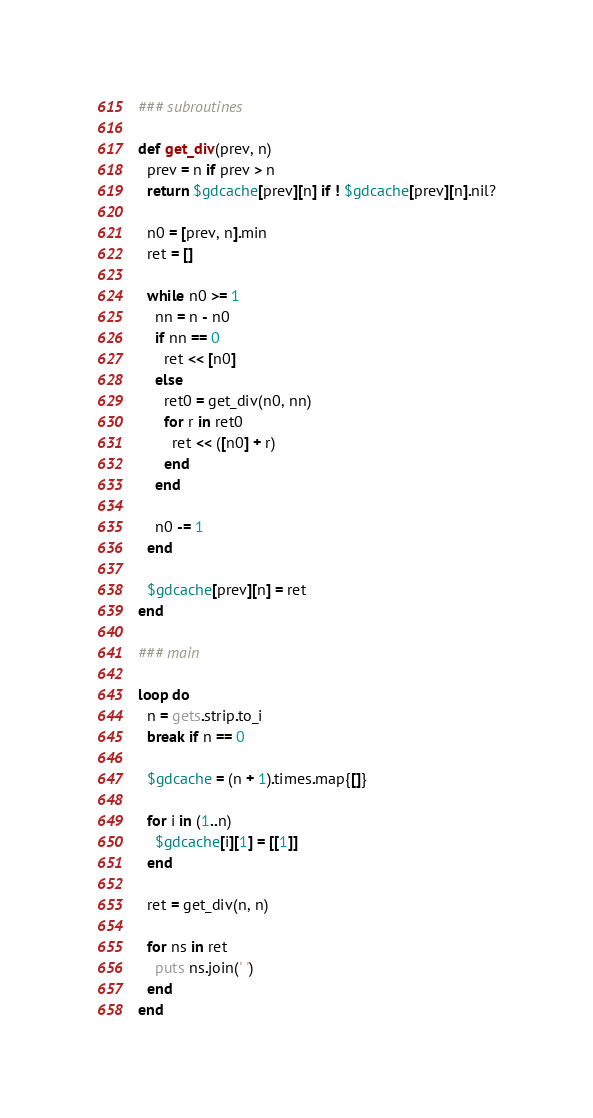<code> <loc_0><loc_0><loc_500><loc_500><_Ruby_>### subroutines

def get_div(prev, n)
  prev = n if prev > n
  return $gdcache[prev][n] if ! $gdcache[prev][n].nil?

  n0 = [prev, n].min
  ret = []

  while n0 >= 1
    nn = n - n0
    if nn == 0
      ret << [n0]
    else
      ret0 = get_div(n0, nn)
      for r in ret0
        ret << ([n0] + r)
      end
    end

    n0 -= 1
  end

  $gdcache[prev][n] = ret
end

### main

loop do
  n = gets.strip.to_i
  break if n == 0

  $gdcache = (n + 1).times.map{[]}

  for i in (1..n)
    $gdcache[i][1] = [[1]]
  end

  ret = get_div(n, n)

  for ns in ret
    puts ns.join(' ')
  end
end</code> 